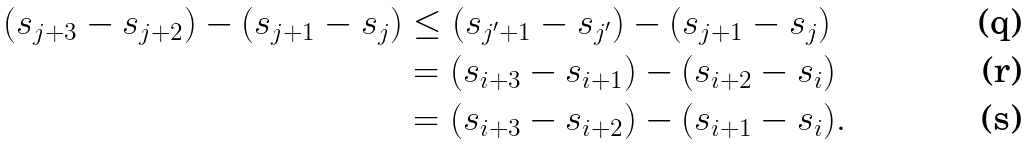Convert formula to latex. <formula><loc_0><loc_0><loc_500><loc_500>( s _ { j + 3 } - s _ { j + 2 } ) - ( s _ { j + 1 } - s _ { j } ) & \leq ( s _ { j ^ { \prime } + 1 } - s _ { j ^ { \prime } } ) - ( s _ { j + 1 } - s _ { j } ) \\ & = ( s _ { i + 3 } - s _ { i + 1 } ) - ( s _ { i + 2 } - s _ { i } ) \\ & = ( s _ { i + 3 } - s _ { i + 2 } ) - ( s _ { i + 1 } - s _ { i } ) .</formula> 